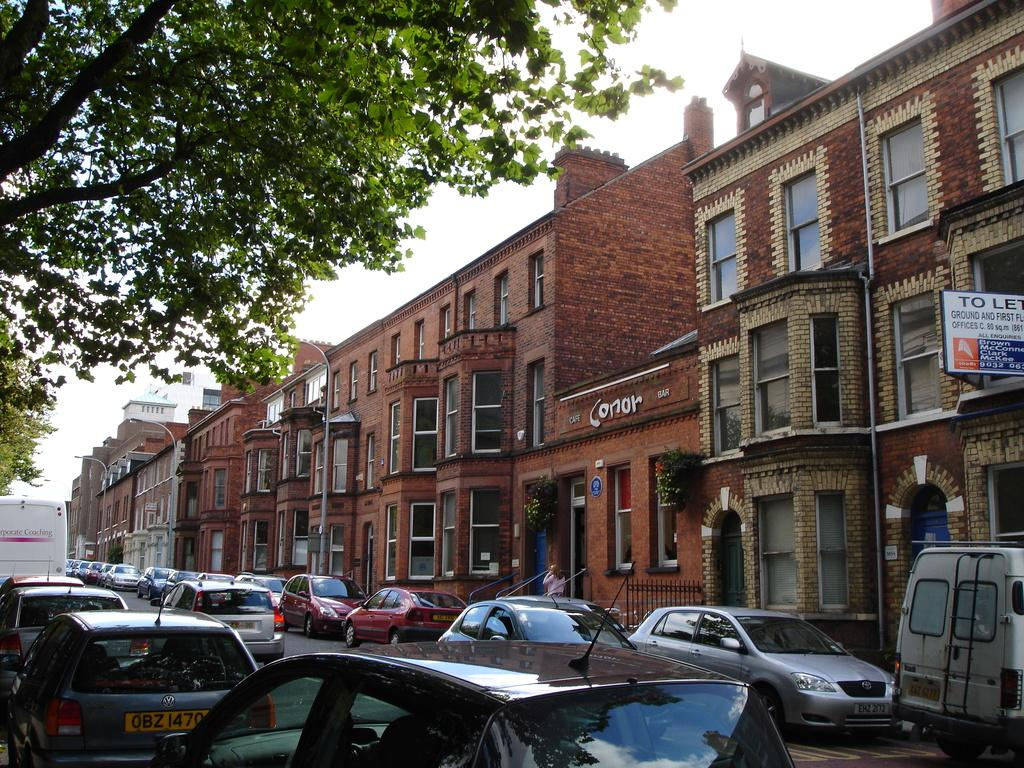<image>
Describe the image concisely. The building in the middle is known as Conor bar. 